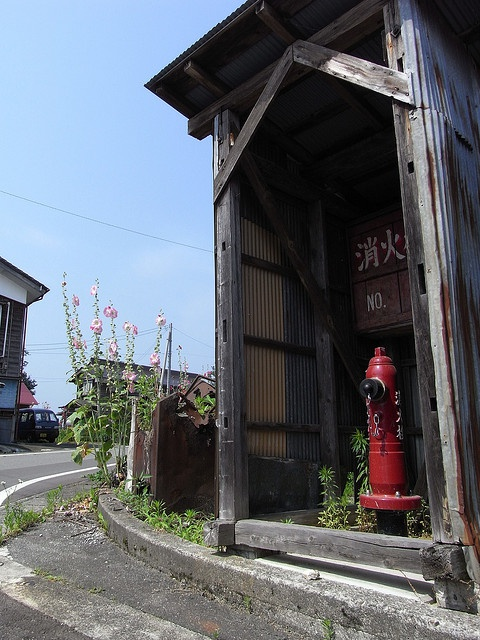Describe the objects in this image and their specific colors. I can see fire hydrant in lightblue, black, maroon, and brown tones and car in lightblue, black, navy, and gray tones in this image. 